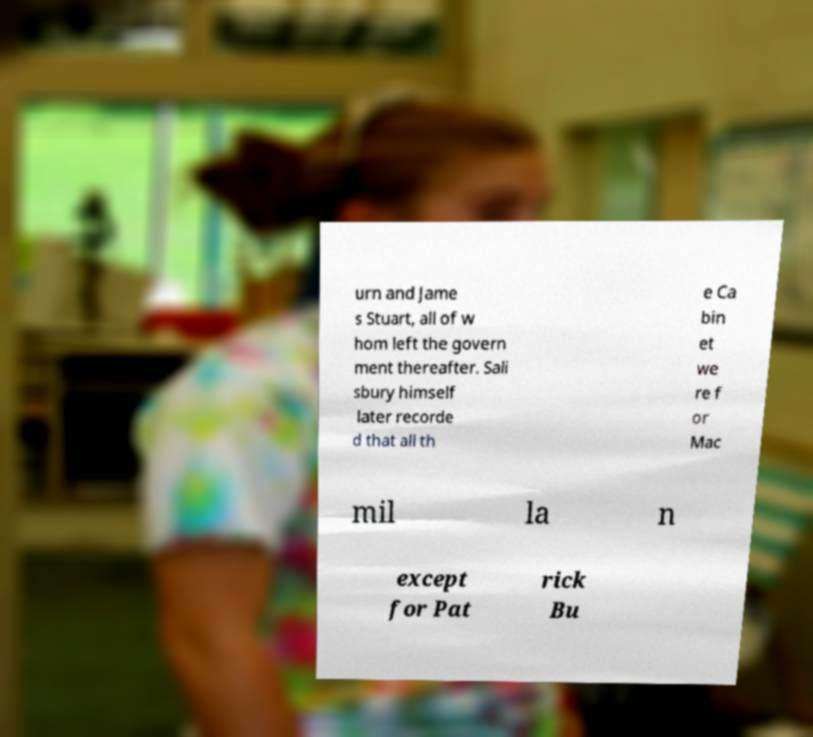Can you accurately transcribe the text from the provided image for me? urn and Jame s Stuart, all of w hom left the govern ment thereafter. Sali sbury himself later recorde d that all th e Ca bin et we re f or Mac mil la n except for Pat rick Bu 